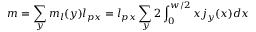Convert formula to latex. <formula><loc_0><loc_0><loc_500><loc_500>m = \sum _ { y } m _ { l } ( y ) l _ { p x } = l _ { p x } \sum _ { y } 2 \int _ { 0 } ^ { w / 2 } x j _ { y } ( x ) d x</formula> 